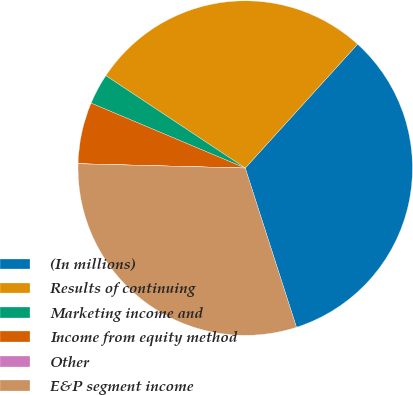<chart> <loc_0><loc_0><loc_500><loc_500><pie_chart><fcel>(In millions)<fcel>Results of continuing<fcel>Marketing income and<fcel>Income from equity method<fcel>Other<fcel>E&P segment income<nl><fcel>33.32%<fcel>27.4%<fcel>2.97%<fcel>5.93%<fcel>0.01%<fcel>30.36%<nl></chart> 